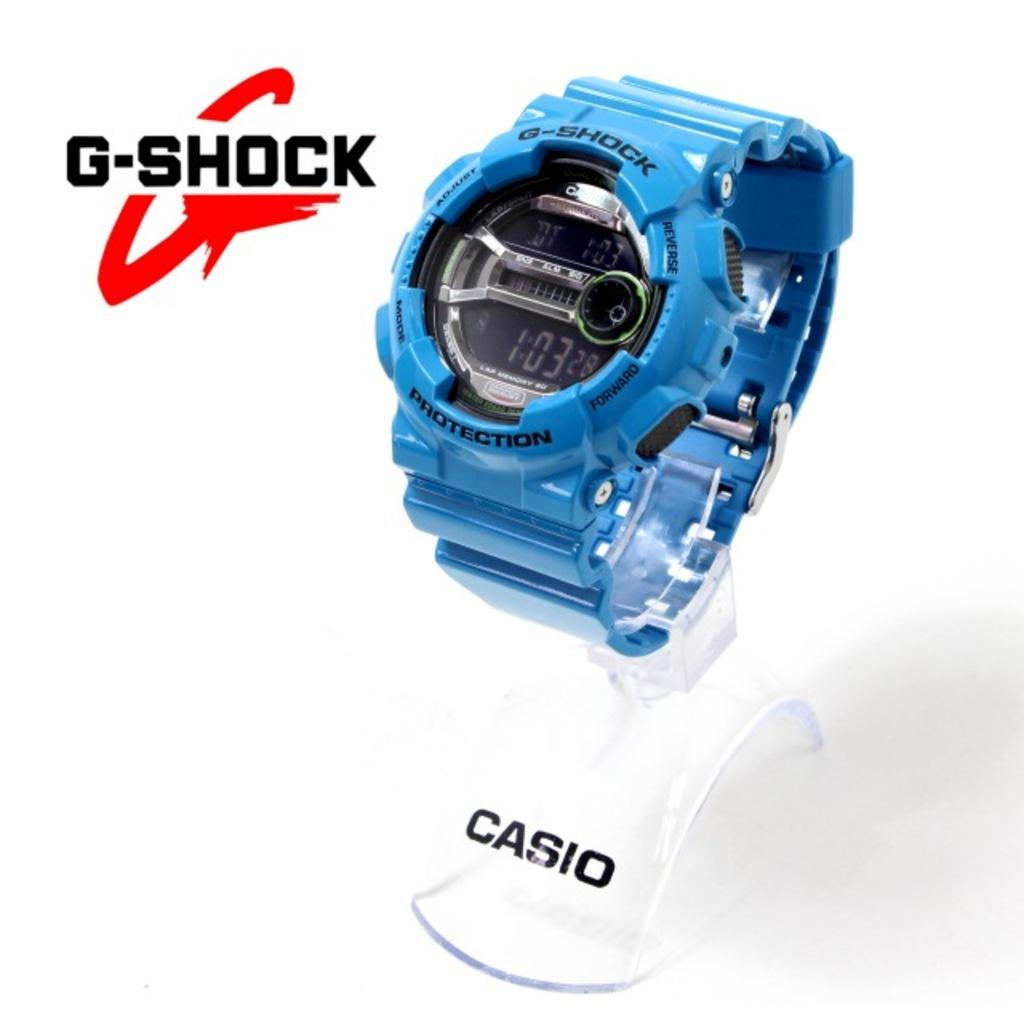<image>
Create a compact narrative representing the image presented. a blue Casio watch shows the time as 1:03 